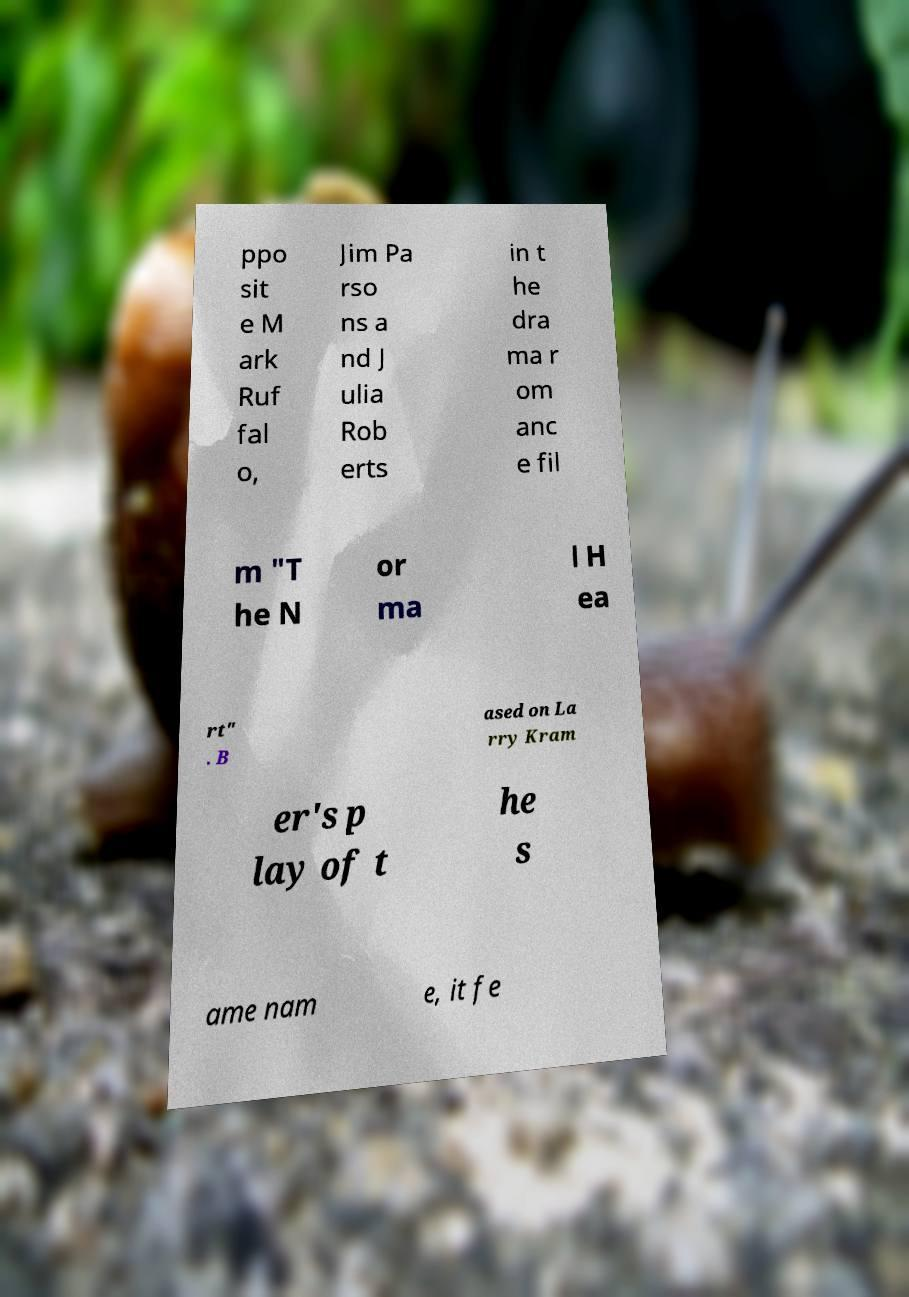Can you accurately transcribe the text from the provided image for me? ppo sit e M ark Ruf fal o, Jim Pa rso ns a nd J ulia Rob erts in t he dra ma r om anc e fil m "T he N or ma l H ea rt" . B ased on La rry Kram er's p lay of t he s ame nam e, it fe 